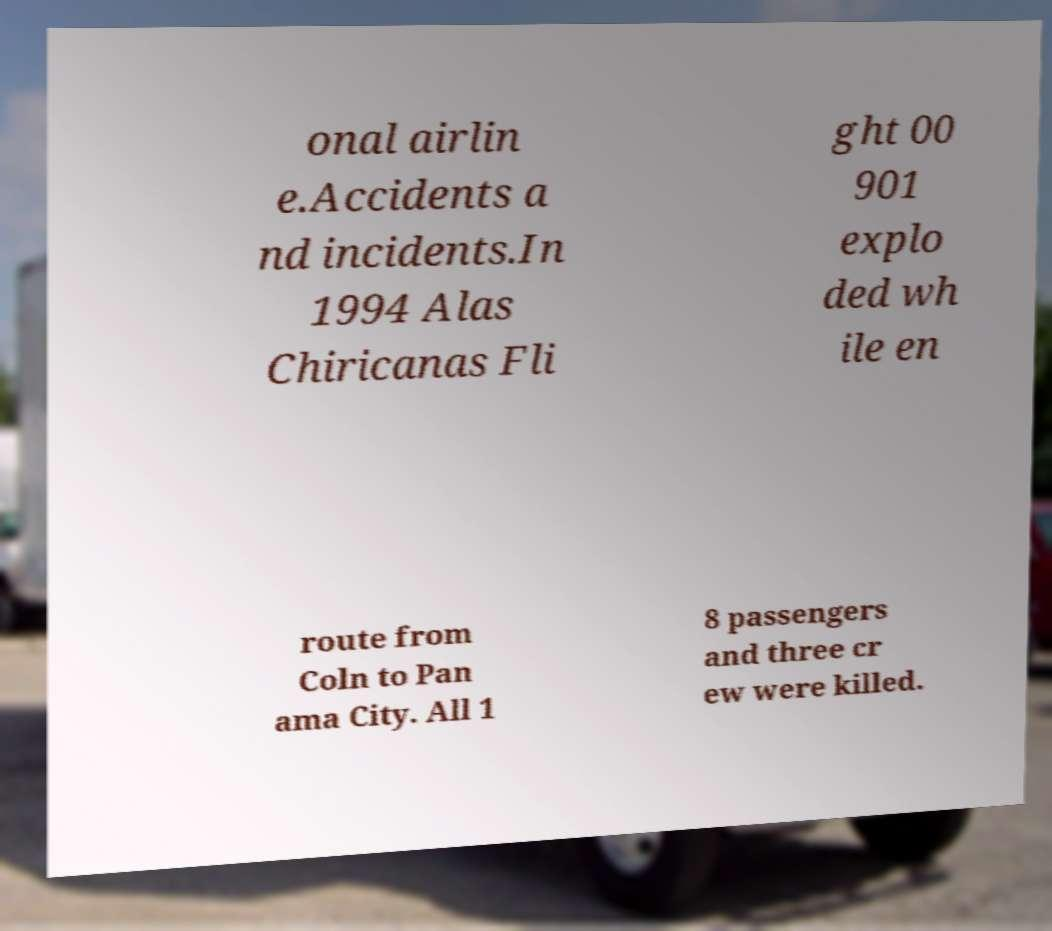Please read and relay the text visible in this image. What does it say? onal airlin e.Accidents a nd incidents.In 1994 Alas Chiricanas Fli ght 00 901 explo ded wh ile en route from Coln to Pan ama City. All 1 8 passengers and three cr ew were killed. 